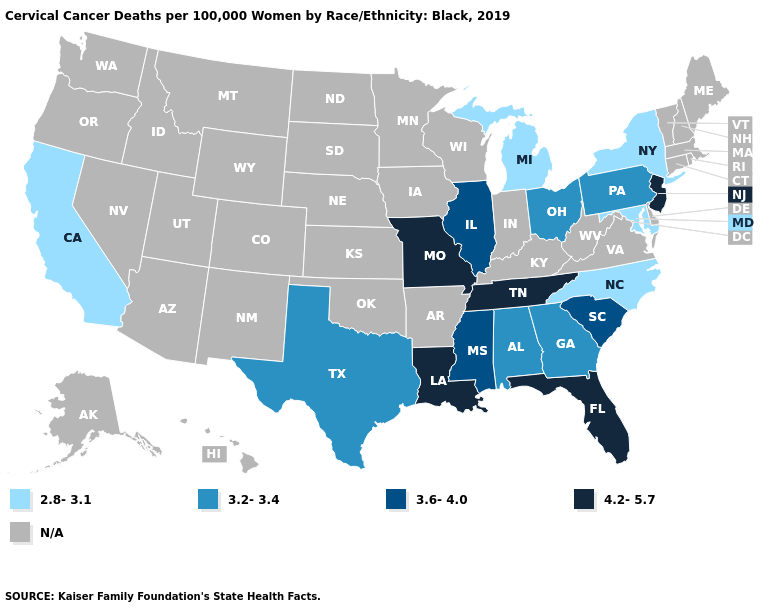What is the lowest value in the MidWest?
Keep it brief. 2.8-3.1. Name the states that have a value in the range 4.2-5.7?
Give a very brief answer. Florida, Louisiana, Missouri, New Jersey, Tennessee. What is the value of Hawaii?
Write a very short answer. N/A. Does Missouri have the highest value in the USA?
Keep it brief. Yes. What is the value of California?
Give a very brief answer. 2.8-3.1. Does the first symbol in the legend represent the smallest category?
Concise answer only. Yes. Name the states that have a value in the range 3.6-4.0?
Be succinct. Illinois, Mississippi, South Carolina. Among the states that border South Carolina , which have the lowest value?
Answer briefly. North Carolina. Name the states that have a value in the range 4.2-5.7?
Concise answer only. Florida, Louisiana, Missouri, New Jersey, Tennessee. What is the value of Michigan?
Quick response, please. 2.8-3.1. Which states have the lowest value in the USA?
Quick response, please. California, Maryland, Michigan, New York, North Carolina. Name the states that have a value in the range 2.8-3.1?
Be succinct. California, Maryland, Michigan, New York, North Carolina. Name the states that have a value in the range 3.6-4.0?
Be succinct. Illinois, Mississippi, South Carolina. 